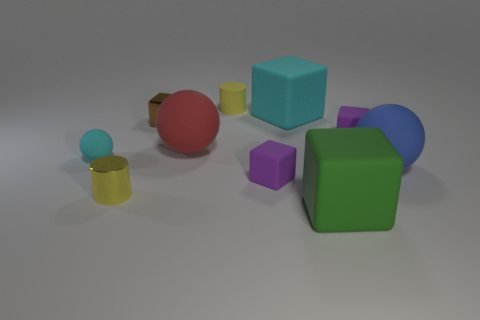Is the number of big green cubes that are in front of the blue object less than the number of brown metal cubes?
Offer a very short reply. No. Is the green object the same shape as the brown thing?
Give a very brief answer. Yes. How big is the matte sphere to the right of the yellow cylinder that is to the right of the small yellow cylinder that is on the left side of the big red ball?
Give a very brief answer. Large. What is the material of the blue object that is the same shape as the small cyan object?
Your response must be concise. Rubber. Is there any other thing that has the same size as the yellow matte thing?
Your response must be concise. Yes. There is a ball in front of the cyan rubber thing left of the small yellow rubber object; what is its size?
Offer a very short reply. Large. What color is the small metallic cylinder?
Offer a terse response. Yellow. There is a purple cube left of the large green cube; how many blue spheres are left of it?
Keep it short and to the point. 0. There is a tiny object that is on the left side of the small metal cylinder; is there a green object that is left of it?
Your answer should be compact. No. Are there any objects left of the red ball?
Your response must be concise. Yes. 